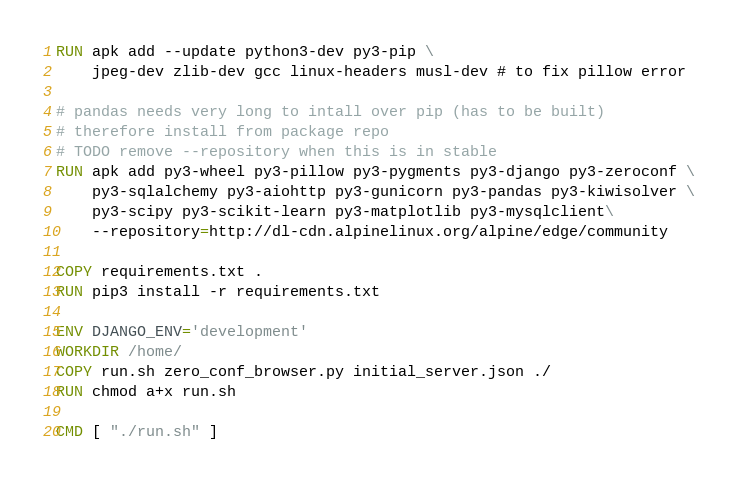<code> <loc_0><loc_0><loc_500><loc_500><_Dockerfile_>
RUN apk add --update python3-dev py3-pip \
    jpeg-dev zlib-dev gcc linux-headers musl-dev # to fix pillow error 

# pandas needs very long to intall over pip (has to be built)
# therefore install from package repo
# TODO remove --repository when this is in stable
RUN apk add py3-wheel py3-pillow py3-pygments py3-django py3-zeroconf \
    py3-sqlalchemy py3-aiohttp py3-gunicorn py3-pandas py3-kiwisolver \
    py3-scipy py3-scikit-learn py3-matplotlib py3-mysqlclient\
    --repository=http://dl-cdn.alpinelinux.org/alpine/edge/community

COPY requirements.txt .
RUN pip3 install -r requirements.txt

ENV DJANGO_ENV='development'
WORKDIR /home/
COPY run.sh zero_conf_browser.py initial_server.json ./
RUN chmod a+x run.sh

CMD [ "./run.sh" ]</code> 